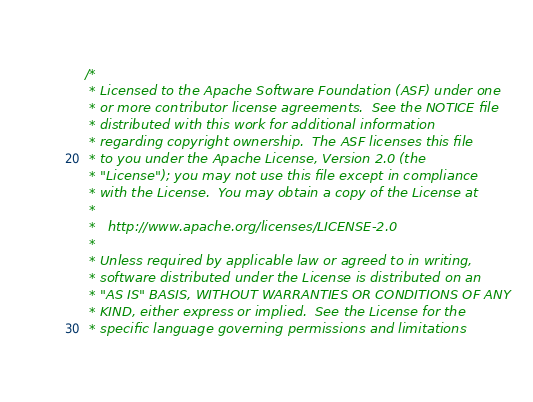<code> <loc_0><loc_0><loc_500><loc_500><_Cuda_>/*
 * Licensed to the Apache Software Foundation (ASF) under one
 * or more contributor license agreements.  See the NOTICE file
 * distributed with this work for additional information
 * regarding copyright ownership.  The ASF licenses this file
 * to you under the Apache License, Version 2.0 (the
 * "License"); you may not use this file except in compliance
 * with the License.  You may obtain a copy of the License at
 *
 *   http://www.apache.org/licenses/LICENSE-2.0
 *
 * Unless required by applicable law or agreed to in writing,
 * software distributed under the License is distributed on an
 * "AS IS" BASIS, WITHOUT WARRANTIES OR CONDITIONS OF ANY
 * KIND, either express or implied.  See the License for the
 * specific language governing permissions and limitations</code> 